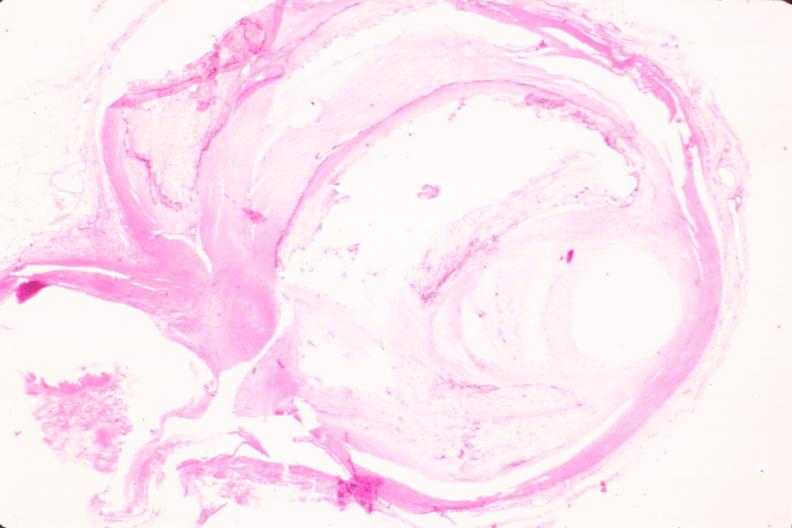s side present?
Answer the question using a single word or phrase. No 